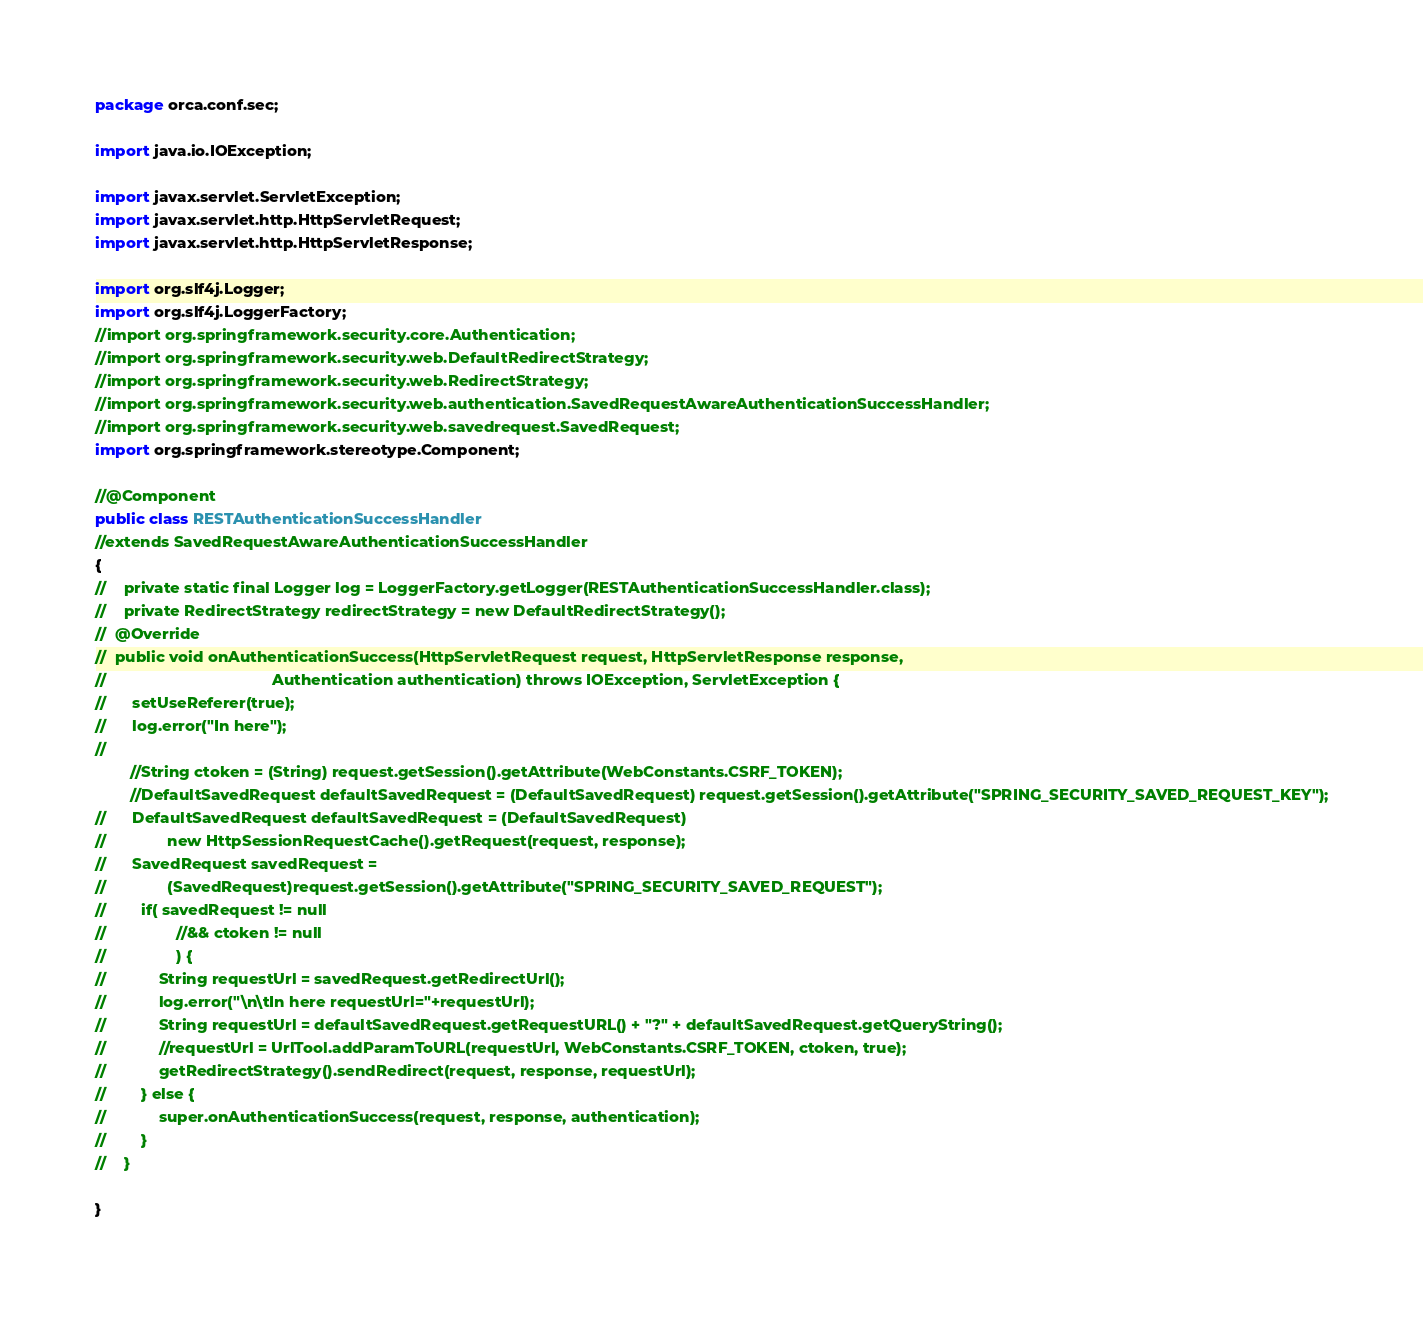Convert code to text. <code><loc_0><loc_0><loc_500><loc_500><_Java_>package orca.conf.sec;

import java.io.IOException;

import javax.servlet.ServletException;
import javax.servlet.http.HttpServletRequest;
import javax.servlet.http.HttpServletResponse;

import org.slf4j.Logger;
import org.slf4j.LoggerFactory;
//import org.springframework.security.core.Authentication;
//import org.springframework.security.web.DefaultRedirectStrategy;
//import org.springframework.security.web.RedirectStrategy;
//import org.springframework.security.web.authentication.SavedRequestAwareAuthenticationSuccessHandler;
//import org.springframework.security.web.savedrequest.SavedRequest;
import org.springframework.stereotype.Component;

//@Component
public class RESTAuthenticationSuccessHandler 
//extends SavedRequestAwareAuthenticationSuccessHandler 
{
//    private static final Logger log = LoggerFactory.getLogger(RESTAuthenticationSuccessHandler.class);
//    private RedirectStrategy redirectStrategy = new DefaultRedirectStrategy();
//	@Override
//	public void onAuthenticationSuccess(HttpServletRequest request, HttpServletResponse response,
//	                                    Authentication authentication) throws IOException, ServletException {
//	    setUseReferer(true);
//	    log.error("In here");
//	    
        //String ctoken = (String) request.getSession().getAttribute(WebConstants.CSRF_TOKEN);
        //DefaultSavedRequest defaultSavedRequest = (DefaultSavedRequest) request.getSession().getAttribute("SPRING_SECURITY_SAVED_REQUEST_KEY");
//	    DefaultSavedRequest defaultSavedRequest = (DefaultSavedRequest)
//	            new HttpSessionRequestCache().getRequest(request, response);
//	    SavedRequest savedRequest =
//	            (SavedRequest)request.getSession().getAttribute("SPRING_SECURITY_SAVED_REQUEST");
//        if( savedRequest != null 
//                //&& ctoken != null 
//                ) {
//            String requestUrl = savedRequest.getRedirectUrl();
//            log.error("\n\tIn here requestUrl="+requestUrl);
//            String requestUrl = defaultSavedRequest.getRequestURL() + "?" + defaultSavedRequest.getQueryString();
//            //requestUrl = UrlTool.addParamToURL(requestUrl, WebConstants.CSRF_TOKEN, ctoken, true);
//            getRedirectStrategy().sendRedirect(request, response, requestUrl);
//        } else {
//            super.onAuthenticationSuccess(request, response, authentication);
//        }
//    }

}</code> 